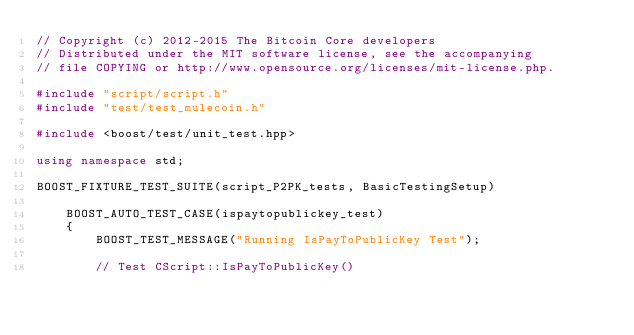Convert code to text. <code><loc_0><loc_0><loc_500><loc_500><_C++_>// Copyright (c) 2012-2015 The Bitcoin Core developers
// Distributed under the MIT software license, see the accompanying
// file COPYING or http://www.opensource.org/licenses/mit-license.php.

#include "script/script.h"
#include "test/test_mulecoin.h"

#include <boost/test/unit_test.hpp>

using namespace std;

BOOST_FIXTURE_TEST_SUITE(script_P2PK_tests, BasicTestingSetup)

    BOOST_AUTO_TEST_CASE(ispaytopublickey_test)
    {
        BOOST_TEST_MESSAGE("Running IsPayToPublicKey Test");

        // Test CScript::IsPayToPublicKey()</code> 